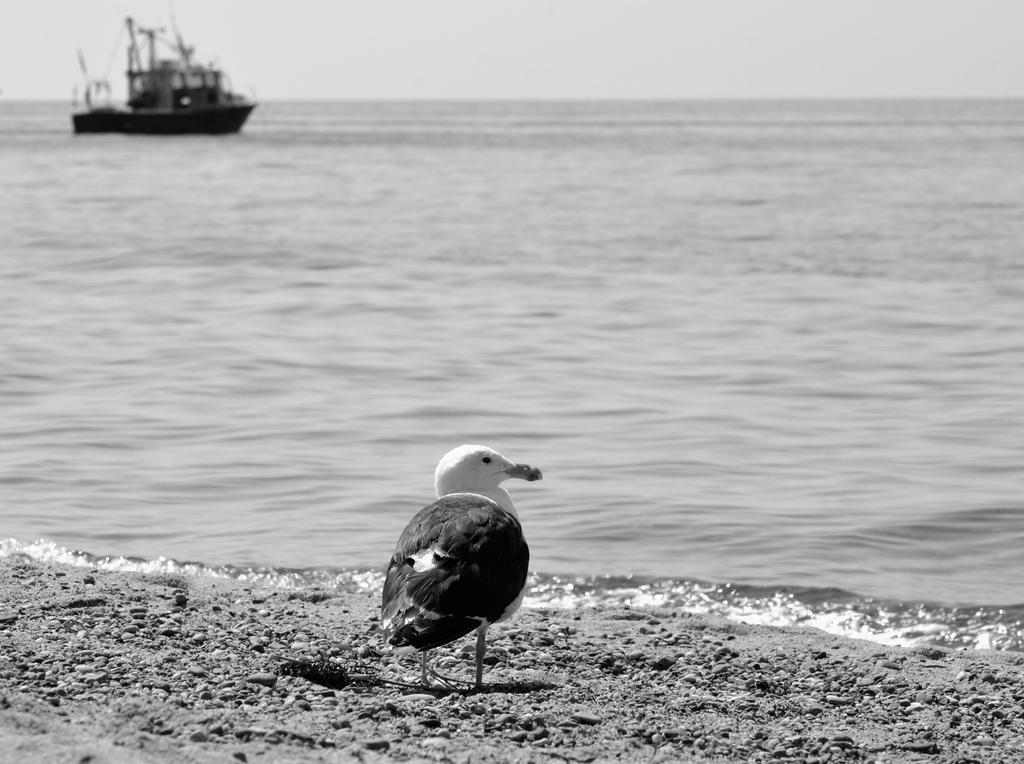Please provide a concise description of this image. In this image in the foreground there is one bird, at the bottom there is sand and in the center there is a river. In the river there is one ship. 